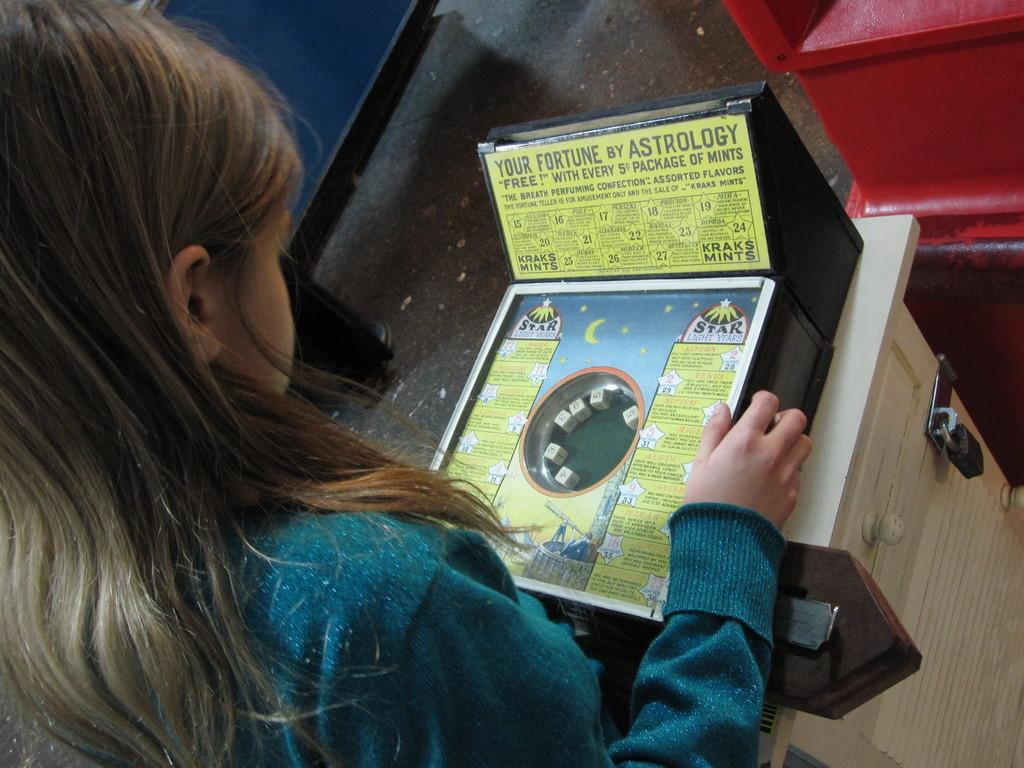What is present in the image? There is a person in the image. Can you describe the person's attire? The person is wearing clothes. What is the person looking at in the image? The person is looking at a game box. What type of noise is the clam making in the image? There is no clam present in the image, so it cannot be making any noise. 